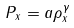Convert formula to latex. <formula><loc_0><loc_0><loc_500><loc_500>P _ { x } = a \rho _ { x } ^ { \gamma }</formula> 